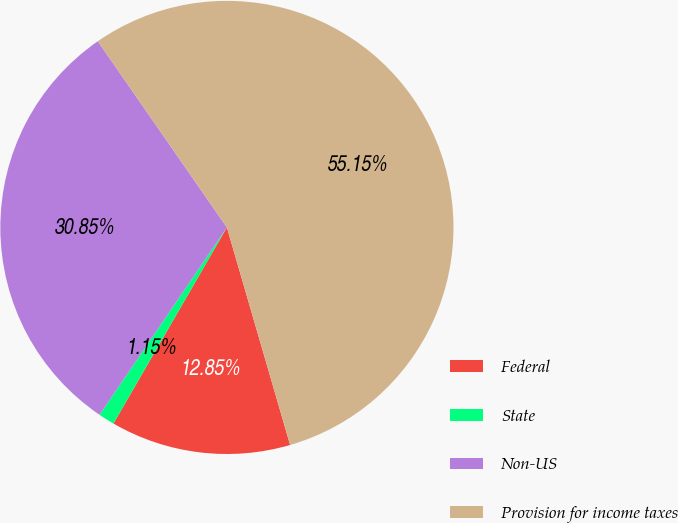Convert chart to OTSL. <chart><loc_0><loc_0><loc_500><loc_500><pie_chart><fcel>Federal<fcel>State<fcel>Non-US<fcel>Provision for income taxes<nl><fcel>12.85%<fcel>1.15%<fcel>30.85%<fcel>55.15%<nl></chart> 